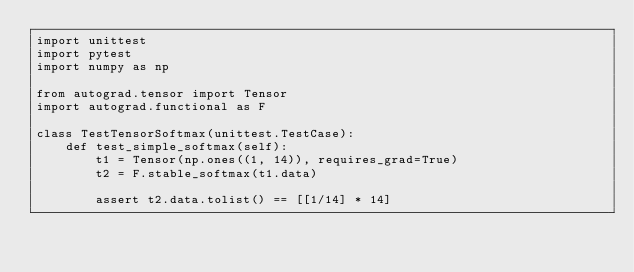<code> <loc_0><loc_0><loc_500><loc_500><_Python_>import unittest
import pytest
import numpy as np

from autograd.tensor import Tensor
import autograd.functional as F

class TestTensorSoftmax(unittest.TestCase):
    def test_simple_softmax(self):
        t1 = Tensor(np.ones((1, 14)), requires_grad=True)
        t2 = F.stable_softmax(t1.data)
        
        assert t2.data.tolist() == [[1/14] * 14]</code> 